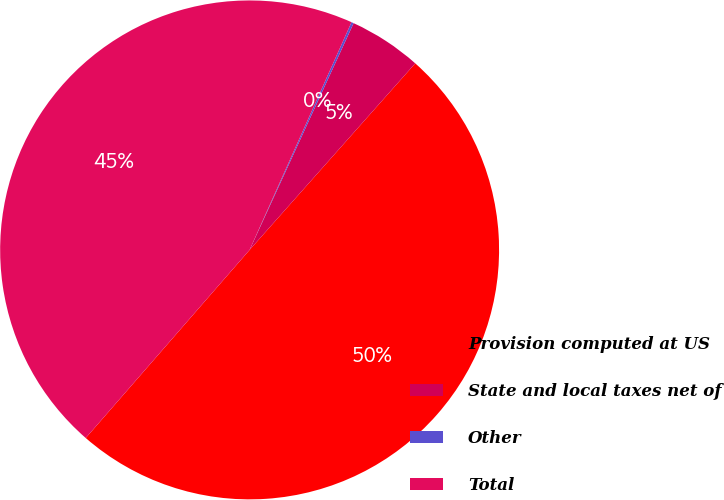Convert chart. <chart><loc_0><loc_0><loc_500><loc_500><pie_chart><fcel>Provision computed at US<fcel>State and local taxes net of<fcel>Other<fcel>Total<nl><fcel>49.85%<fcel>4.71%<fcel>0.15%<fcel>45.29%<nl></chart> 